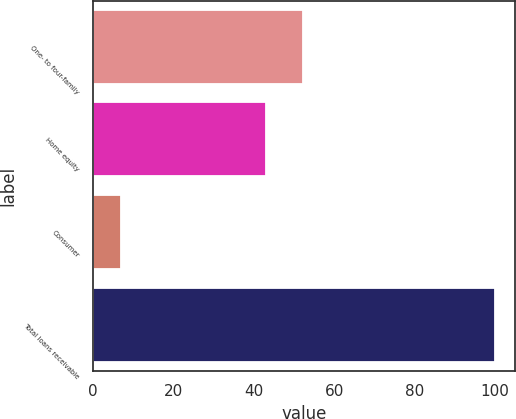Convert chart to OTSL. <chart><loc_0><loc_0><loc_500><loc_500><bar_chart><fcel>One- to four-family<fcel>Home equity<fcel>Consumer<fcel>Total loans receivable<nl><fcel>52.3<fcel>43<fcel>7<fcel>100<nl></chart> 